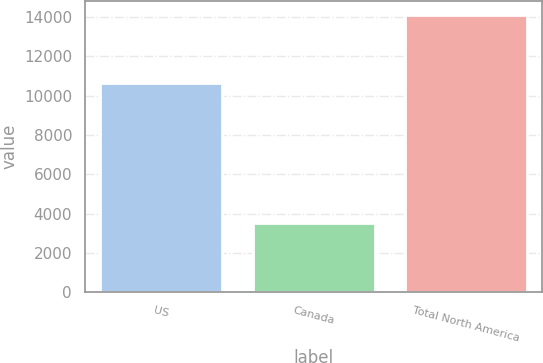Convert chart to OTSL. <chart><loc_0><loc_0><loc_500><loc_500><bar_chart><fcel>US<fcel>Canada<fcel>Total North America<nl><fcel>10624<fcel>3498<fcel>14122<nl></chart> 